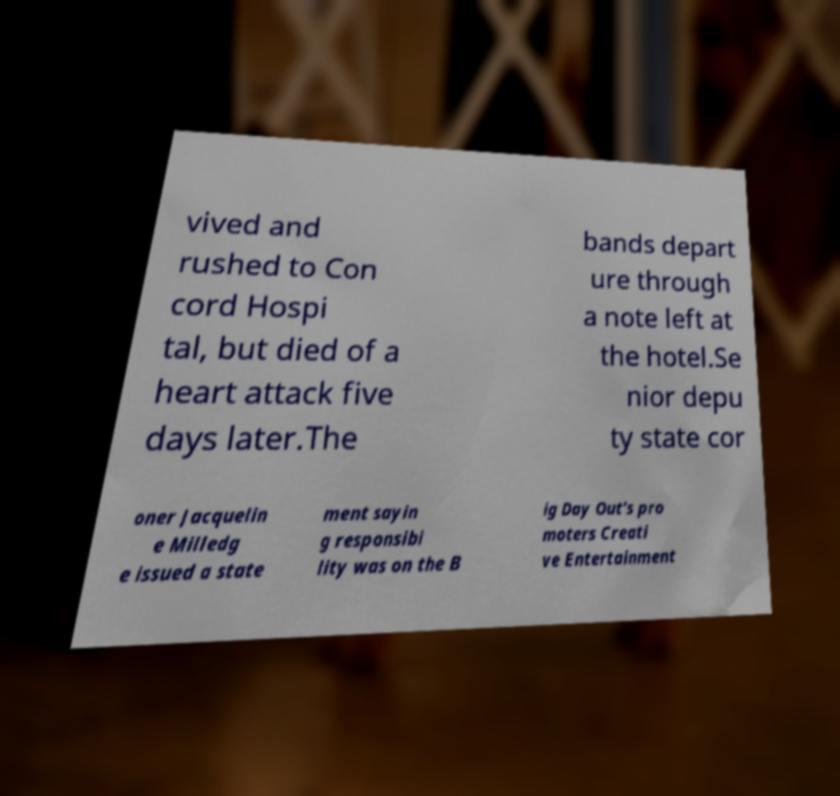What messages or text are displayed in this image? I need them in a readable, typed format. vived and rushed to Con cord Hospi tal, but died of a heart attack five days later.The bands depart ure through a note left at the hotel.Se nior depu ty state cor oner Jacquelin e Milledg e issued a state ment sayin g responsibi lity was on the B ig Day Out's pro moters Creati ve Entertainment 